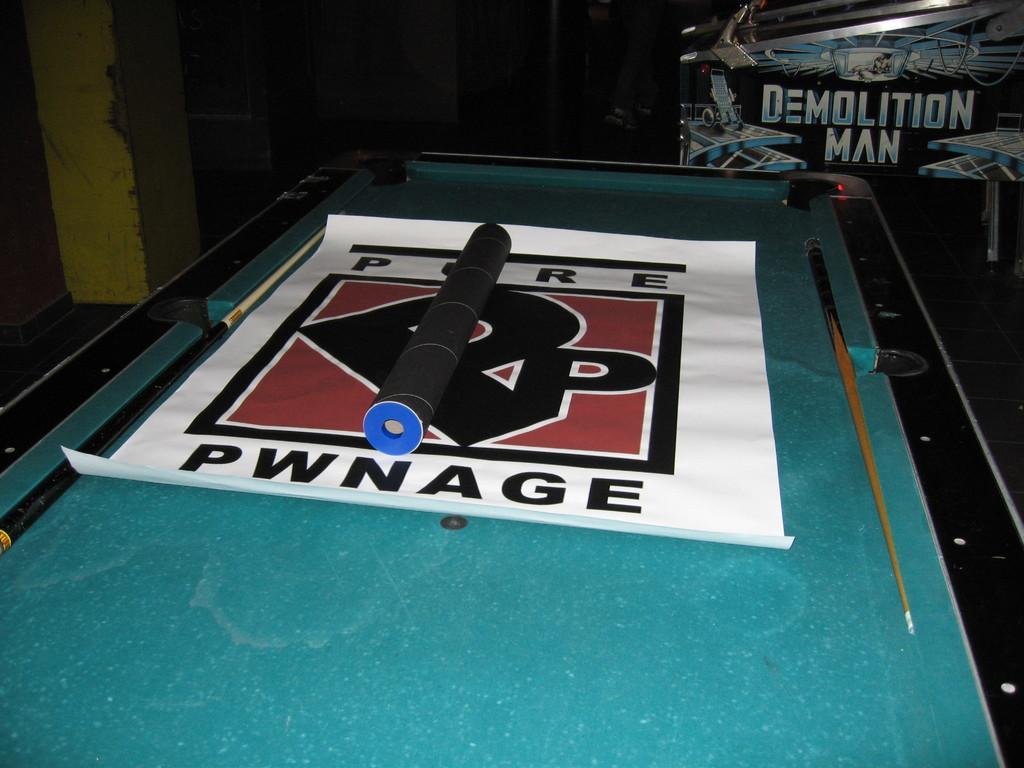Could you give a brief overview of what you see in this image? In this image there are snooker cue sticks , banner , and an object on the snookers board , and in the background there is a board. 